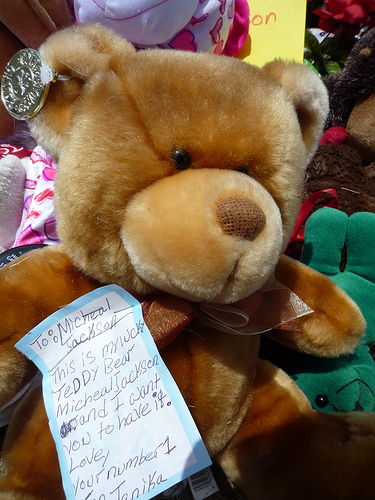Read and extract the text from this image. on This is myluck TeDDy Bear Tanika 1 number 1 your Love if have to you want I sand Beat Jackser Micheal Jackson Jackson To 